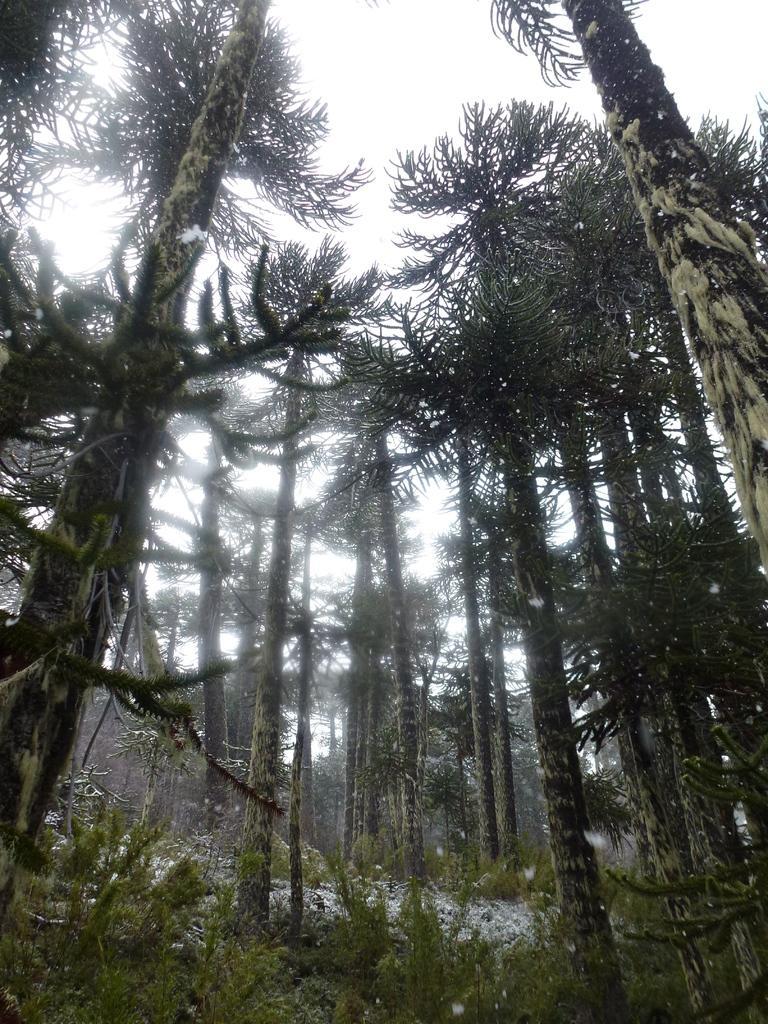Could you give a brief overview of what you see in this image? In this picture there is greenery around the area of the image. 